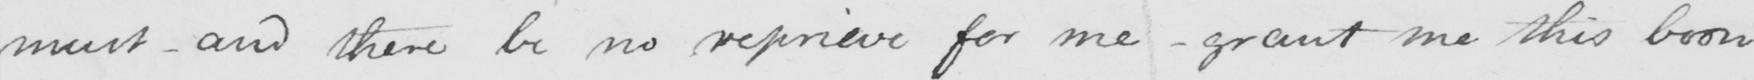Transcribe the text shown in this historical manuscript line. must  _  and there be no reprieve for me  _  grant me this boon 